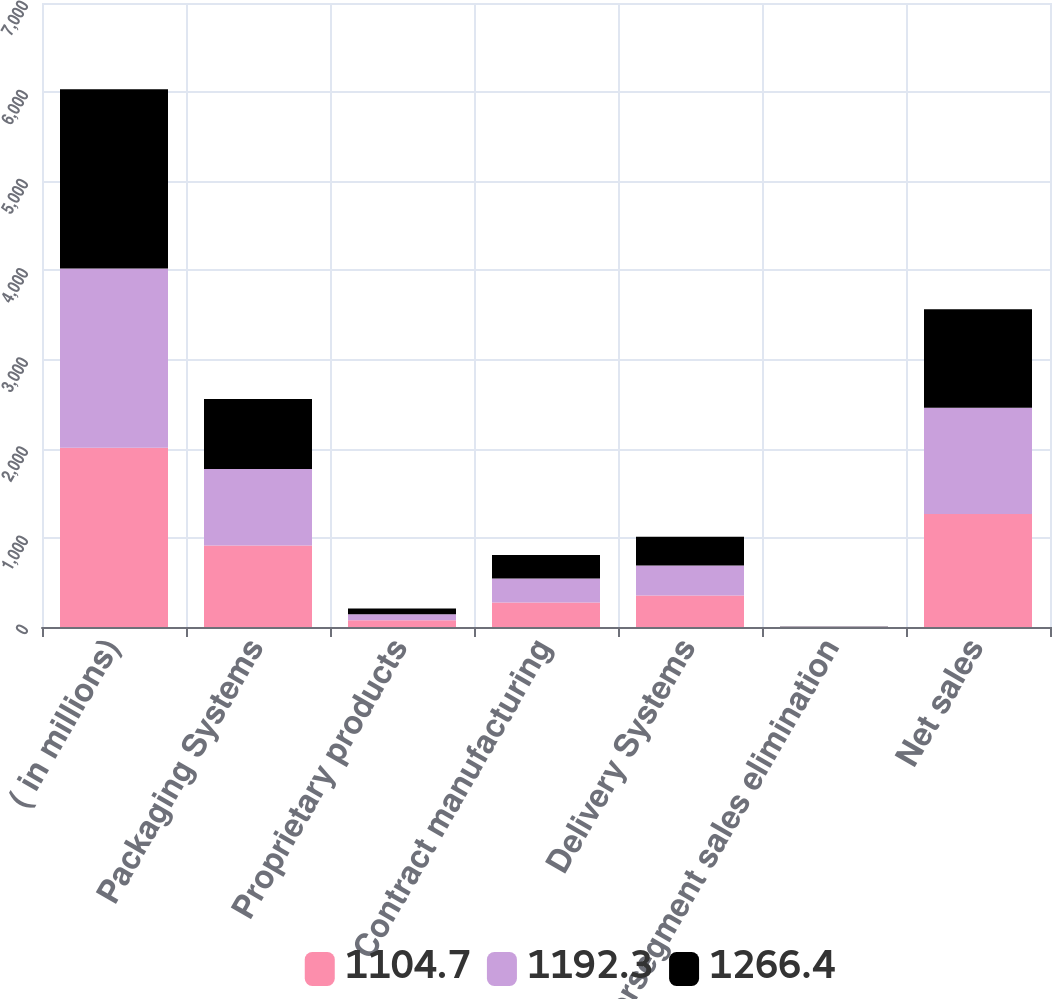Convert chart to OTSL. <chart><loc_0><loc_0><loc_500><loc_500><stacked_bar_chart><ecel><fcel>( in millions)<fcel>Packaging Systems<fcel>Proprietary products<fcel>Contract manufacturing<fcel>Delivery Systems<fcel>Intersegment sales elimination<fcel>Net sales<nl><fcel>1104.7<fcel>2012<fcel>915.1<fcel>77<fcel>275.1<fcel>352.1<fcel>0.8<fcel>1266.4<nl><fcel>1192.3<fcel>2011<fcel>857.4<fcel>67.4<fcel>269.3<fcel>336.7<fcel>1.8<fcel>1192.3<nl><fcel>1266.4<fcel>2010<fcel>785<fcel>62.2<fcel>261.9<fcel>324.1<fcel>4.4<fcel>1104.7<nl></chart> 